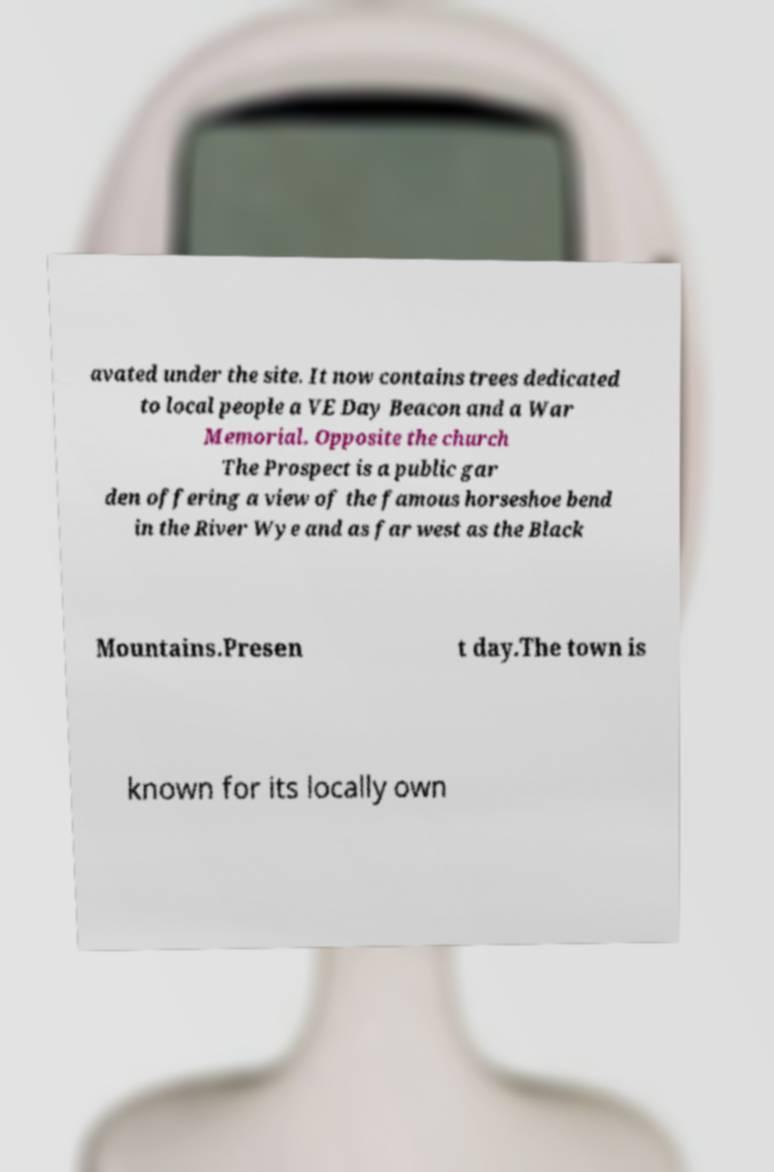Please read and relay the text visible in this image. What does it say? avated under the site. It now contains trees dedicated to local people a VE Day Beacon and a War Memorial. Opposite the church The Prospect is a public gar den offering a view of the famous horseshoe bend in the River Wye and as far west as the Black Mountains.Presen t day.The town is known for its locally own 